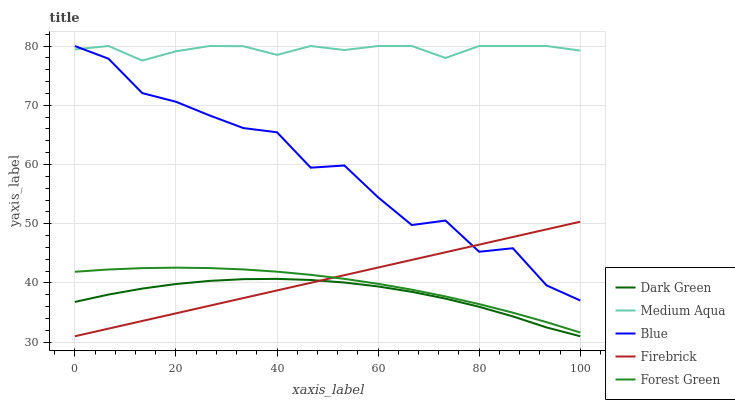Does Dark Green have the minimum area under the curve?
Answer yes or no. Yes. Does Medium Aqua have the maximum area under the curve?
Answer yes or no. Yes. Does Firebrick have the minimum area under the curve?
Answer yes or no. No. Does Firebrick have the maximum area under the curve?
Answer yes or no. No. Is Firebrick the smoothest?
Answer yes or no. Yes. Is Blue the roughest?
Answer yes or no. Yes. Is Medium Aqua the smoothest?
Answer yes or no. No. Is Medium Aqua the roughest?
Answer yes or no. No. Does Firebrick have the lowest value?
Answer yes or no. Yes. Does Medium Aqua have the lowest value?
Answer yes or no. No. Does Medium Aqua have the highest value?
Answer yes or no. Yes. Does Firebrick have the highest value?
Answer yes or no. No. Is Dark Green less than Forest Green?
Answer yes or no. Yes. Is Forest Green greater than Dark Green?
Answer yes or no. Yes. Does Medium Aqua intersect Blue?
Answer yes or no. Yes. Is Medium Aqua less than Blue?
Answer yes or no. No. Is Medium Aqua greater than Blue?
Answer yes or no. No. Does Dark Green intersect Forest Green?
Answer yes or no. No. 